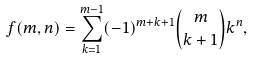<formula> <loc_0><loc_0><loc_500><loc_500>f ( m , n ) = \sum _ { k = 1 } ^ { m - 1 } ( - 1 ) ^ { m + k + 1 } { m \choose k + 1 } k ^ { n } ,</formula> 